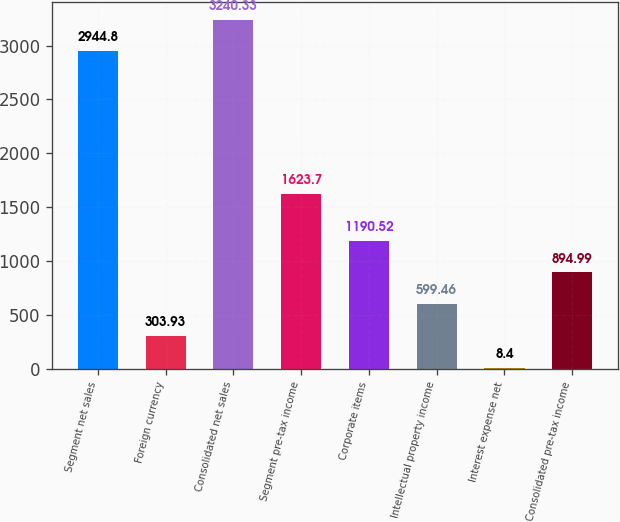<chart> <loc_0><loc_0><loc_500><loc_500><bar_chart><fcel>Segment net sales<fcel>Foreign currency<fcel>Consolidated net sales<fcel>Segment pre-tax income<fcel>Corporate items<fcel>Intellectual property income<fcel>Interest expense net<fcel>Consolidated pre-tax income<nl><fcel>2944.8<fcel>303.93<fcel>3240.33<fcel>1623.7<fcel>1190.52<fcel>599.46<fcel>8.4<fcel>894.99<nl></chart> 